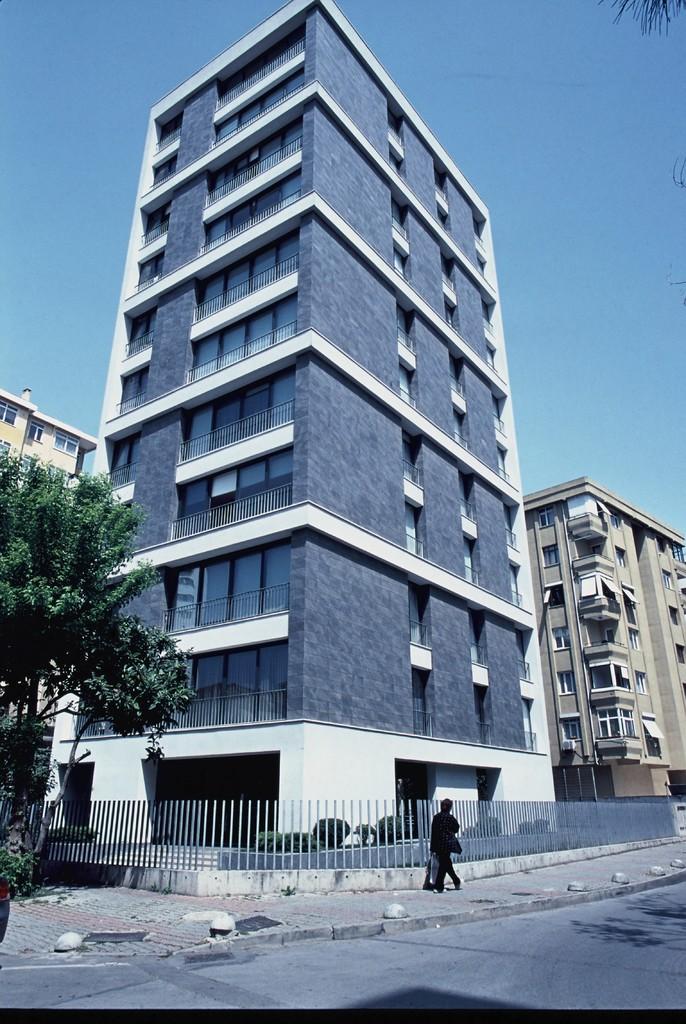Can you describe this image briefly? In this image in the center there is a person standing and there is a fence. In the background there are buildings. On the left side there are trees. 